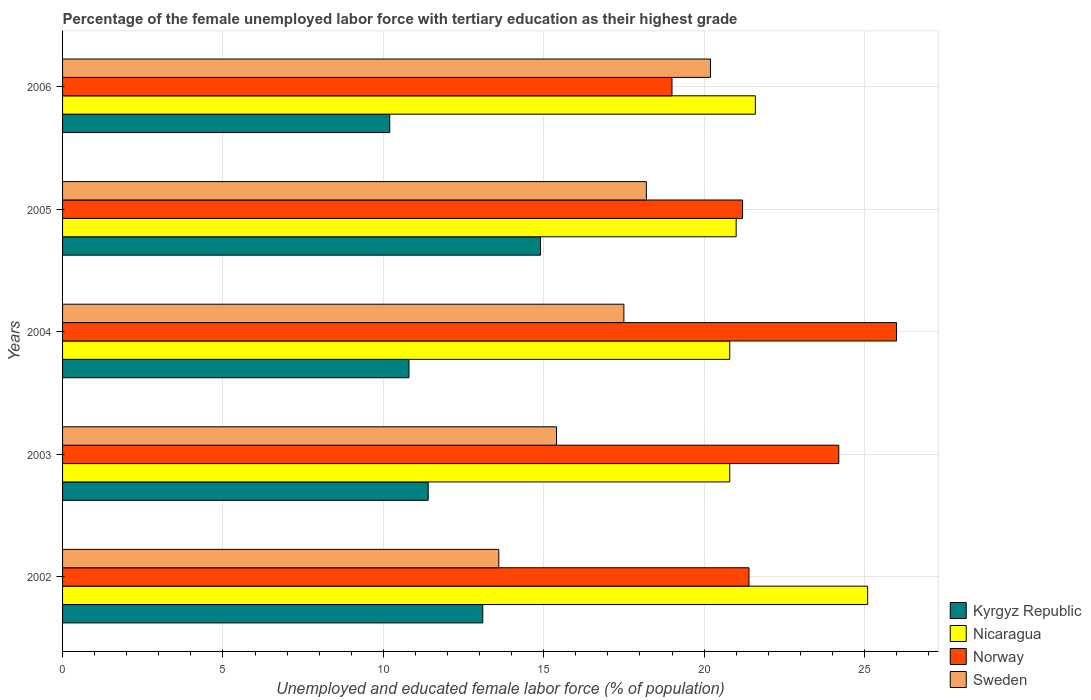How many groups of bars are there?
Your answer should be compact. 5. How many bars are there on the 5th tick from the top?
Your answer should be compact. 4. How many bars are there on the 2nd tick from the bottom?
Provide a short and direct response. 4. What is the percentage of the unemployed female labor force with tertiary education in Sweden in 2003?
Make the answer very short. 15.4. Across all years, what is the minimum percentage of the unemployed female labor force with tertiary education in Kyrgyz Republic?
Offer a terse response. 10.2. In which year was the percentage of the unemployed female labor force with tertiary education in Sweden maximum?
Offer a terse response. 2006. In which year was the percentage of the unemployed female labor force with tertiary education in Norway minimum?
Ensure brevity in your answer.  2006. What is the total percentage of the unemployed female labor force with tertiary education in Nicaragua in the graph?
Your response must be concise. 109.3. What is the difference between the percentage of the unemployed female labor force with tertiary education in Sweden in 2006 and the percentage of the unemployed female labor force with tertiary education in Nicaragua in 2003?
Your answer should be very brief. -0.6. What is the average percentage of the unemployed female labor force with tertiary education in Sweden per year?
Make the answer very short. 16.98. What is the ratio of the percentage of the unemployed female labor force with tertiary education in Sweden in 2002 to that in 2003?
Offer a very short reply. 0.88. Is the percentage of the unemployed female labor force with tertiary education in Nicaragua in 2003 less than that in 2005?
Ensure brevity in your answer.  Yes. What is the difference between the highest and the second highest percentage of the unemployed female labor force with tertiary education in Nicaragua?
Keep it short and to the point. 3.5. What is the difference between the highest and the lowest percentage of the unemployed female labor force with tertiary education in Sweden?
Make the answer very short. 6.6. What does the 4th bar from the top in 2006 represents?
Give a very brief answer. Kyrgyz Republic. What does the 2nd bar from the bottom in 2006 represents?
Your response must be concise. Nicaragua. Is it the case that in every year, the sum of the percentage of the unemployed female labor force with tertiary education in Kyrgyz Republic and percentage of the unemployed female labor force with tertiary education in Nicaragua is greater than the percentage of the unemployed female labor force with tertiary education in Norway?
Your answer should be very brief. Yes. How many bars are there?
Make the answer very short. 20. How many years are there in the graph?
Offer a terse response. 5. Are the values on the major ticks of X-axis written in scientific E-notation?
Keep it short and to the point. No. Does the graph contain any zero values?
Your answer should be very brief. No. How many legend labels are there?
Ensure brevity in your answer.  4. How are the legend labels stacked?
Provide a succinct answer. Vertical. What is the title of the graph?
Give a very brief answer. Percentage of the female unemployed labor force with tertiary education as their highest grade. Does "Belize" appear as one of the legend labels in the graph?
Offer a terse response. No. What is the label or title of the X-axis?
Offer a very short reply. Unemployed and educated female labor force (% of population). What is the Unemployed and educated female labor force (% of population) in Kyrgyz Republic in 2002?
Offer a very short reply. 13.1. What is the Unemployed and educated female labor force (% of population) of Nicaragua in 2002?
Provide a succinct answer. 25.1. What is the Unemployed and educated female labor force (% of population) of Norway in 2002?
Ensure brevity in your answer.  21.4. What is the Unemployed and educated female labor force (% of population) of Sweden in 2002?
Offer a terse response. 13.6. What is the Unemployed and educated female labor force (% of population) of Kyrgyz Republic in 2003?
Offer a terse response. 11.4. What is the Unemployed and educated female labor force (% of population) of Nicaragua in 2003?
Provide a short and direct response. 20.8. What is the Unemployed and educated female labor force (% of population) in Norway in 2003?
Offer a very short reply. 24.2. What is the Unemployed and educated female labor force (% of population) of Sweden in 2003?
Your response must be concise. 15.4. What is the Unemployed and educated female labor force (% of population) of Kyrgyz Republic in 2004?
Keep it short and to the point. 10.8. What is the Unemployed and educated female labor force (% of population) of Nicaragua in 2004?
Your answer should be compact. 20.8. What is the Unemployed and educated female labor force (% of population) in Norway in 2004?
Keep it short and to the point. 26. What is the Unemployed and educated female labor force (% of population) in Kyrgyz Republic in 2005?
Offer a very short reply. 14.9. What is the Unemployed and educated female labor force (% of population) in Nicaragua in 2005?
Your answer should be very brief. 21. What is the Unemployed and educated female labor force (% of population) of Norway in 2005?
Provide a short and direct response. 21.2. What is the Unemployed and educated female labor force (% of population) of Sweden in 2005?
Keep it short and to the point. 18.2. What is the Unemployed and educated female labor force (% of population) in Kyrgyz Republic in 2006?
Provide a short and direct response. 10.2. What is the Unemployed and educated female labor force (% of population) in Nicaragua in 2006?
Give a very brief answer. 21.6. What is the Unemployed and educated female labor force (% of population) of Sweden in 2006?
Offer a terse response. 20.2. Across all years, what is the maximum Unemployed and educated female labor force (% of population) of Kyrgyz Republic?
Offer a very short reply. 14.9. Across all years, what is the maximum Unemployed and educated female labor force (% of population) in Nicaragua?
Your response must be concise. 25.1. Across all years, what is the maximum Unemployed and educated female labor force (% of population) in Norway?
Your answer should be very brief. 26. Across all years, what is the maximum Unemployed and educated female labor force (% of population) of Sweden?
Provide a short and direct response. 20.2. Across all years, what is the minimum Unemployed and educated female labor force (% of population) in Kyrgyz Republic?
Your answer should be compact. 10.2. Across all years, what is the minimum Unemployed and educated female labor force (% of population) of Nicaragua?
Offer a terse response. 20.8. Across all years, what is the minimum Unemployed and educated female labor force (% of population) of Norway?
Keep it short and to the point. 19. Across all years, what is the minimum Unemployed and educated female labor force (% of population) of Sweden?
Your answer should be compact. 13.6. What is the total Unemployed and educated female labor force (% of population) in Kyrgyz Republic in the graph?
Offer a terse response. 60.4. What is the total Unemployed and educated female labor force (% of population) in Nicaragua in the graph?
Make the answer very short. 109.3. What is the total Unemployed and educated female labor force (% of population) in Norway in the graph?
Your answer should be very brief. 111.8. What is the total Unemployed and educated female labor force (% of population) in Sweden in the graph?
Make the answer very short. 84.9. What is the difference between the Unemployed and educated female labor force (% of population) of Norway in 2002 and that in 2004?
Your answer should be compact. -4.6. What is the difference between the Unemployed and educated female labor force (% of population) of Sweden in 2002 and that in 2004?
Ensure brevity in your answer.  -3.9. What is the difference between the Unemployed and educated female labor force (% of population) of Norway in 2002 and that in 2005?
Offer a very short reply. 0.2. What is the difference between the Unemployed and educated female labor force (% of population) of Sweden in 2002 and that in 2005?
Your response must be concise. -4.6. What is the difference between the Unemployed and educated female labor force (% of population) of Kyrgyz Republic in 2002 and that in 2006?
Offer a terse response. 2.9. What is the difference between the Unemployed and educated female labor force (% of population) in Sweden in 2002 and that in 2006?
Keep it short and to the point. -6.6. What is the difference between the Unemployed and educated female labor force (% of population) in Kyrgyz Republic in 2003 and that in 2004?
Your response must be concise. 0.6. What is the difference between the Unemployed and educated female labor force (% of population) of Nicaragua in 2003 and that in 2004?
Your answer should be compact. 0. What is the difference between the Unemployed and educated female labor force (% of population) of Norway in 2003 and that in 2005?
Give a very brief answer. 3. What is the difference between the Unemployed and educated female labor force (% of population) of Sweden in 2003 and that in 2006?
Make the answer very short. -4.8. What is the difference between the Unemployed and educated female labor force (% of population) in Kyrgyz Republic in 2004 and that in 2005?
Make the answer very short. -4.1. What is the difference between the Unemployed and educated female labor force (% of population) in Nicaragua in 2004 and that in 2005?
Ensure brevity in your answer.  -0.2. What is the difference between the Unemployed and educated female labor force (% of population) in Norway in 2004 and that in 2005?
Your response must be concise. 4.8. What is the difference between the Unemployed and educated female labor force (% of population) in Sweden in 2004 and that in 2005?
Provide a succinct answer. -0.7. What is the difference between the Unemployed and educated female labor force (% of population) in Kyrgyz Republic in 2004 and that in 2006?
Offer a terse response. 0.6. What is the difference between the Unemployed and educated female labor force (% of population) of Nicaragua in 2004 and that in 2006?
Your answer should be compact. -0.8. What is the difference between the Unemployed and educated female labor force (% of population) in Sweden in 2004 and that in 2006?
Offer a very short reply. -2.7. What is the difference between the Unemployed and educated female labor force (% of population) in Sweden in 2005 and that in 2006?
Ensure brevity in your answer.  -2. What is the difference between the Unemployed and educated female labor force (% of population) of Kyrgyz Republic in 2002 and the Unemployed and educated female labor force (% of population) of Norway in 2003?
Keep it short and to the point. -11.1. What is the difference between the Unemployed and educated female labor force (% of population) in Nicaragua in 2002 and the Unemployed and educated female labor force (% of population) in Norway in 2003?
Your answer should be compact. 0.9. What is the difference between the Unemployed and educated female labor force (% of population) in Nicaragua in 2002 and the Unemployed and educated female labor force (% of population) in Sweden in 2003?
Make the answer very short. 9.7. What is the difference between the Unemployed and educated female labor force (% of population) of Kyrgyz Republic in 2002 and the Unemployed and educated female labor force (% of population) of Nicaragua in 2004?
Keep it short and to the point. -7.7. What is the difference between the Unemployed and educated female labor force (% of population) in Kyrgyz Republic in 2002 and the Unemployed and educated female labor force (% of population) in Norway in 2004?
Your answer should be very brief. -12.9. What is the difference between the Unemployed and educated female labor force (% of population) of Nicaragua in 2002 and the Unemployed and educated female labor force (% of population) of Norway in 2004?
Make the answer very short. -0.9. What is the difference between the Unemployed and educated female labor force (% of population) of Nicaragua in 2002 and the Unemployed and educated female labor force (% of population) of Sweden in 2004?
Offer a terse response. 7.6. What is the difference between the Unemployed and educated female labor force (% of population) in Norway in 2002 and the Unemployed and educated female labor force (% of population) in Sweden in 2004?
Your answer should be compact. 3.9. What is the difference between the Unemployed and educated female labor force (% of population) in Kyrgyz Republic in 2002 and the Unemployed and educated female labor force (% of population) in Nicaragua in 2005?
Your answer should be compact. -7.9. What is the difference between the Unemployed and educated female labor force (% of population) in Kyrgyz Republic in 2002 and the Unemployed and educated female labor force (% of population) in Norway in 2005?
Offer a very short reply. -8.1. What is the difference between the Unemployed and educated female labor force (% of population) in Kyrgyz Republic in 2002 and the Unemployed and educated female labor force (% of population) in Sweden in 2005?
Make the answer very short. -5.1. What is the difference between the Unemployed and educated female labor force (% of population) of Norway in 2002 and the Unemployed and educated female labor force (% of population) of Sweden in 2005?
Make the answer very short. 3.2. What is the difference between the Unemployed and educated female labor force (% of population) of Kyrgyz Republic in 2002 and the Unemployed and educated female labor force (% of population) of Nicaragua in 2006?
Your answer should be very brief. -8.5. What is the difference between the Unemployed and educated female labor force (% of population) in Kyrgyz Republic in 2002 and the Unemployed and educated female labor force (% of population) in Norway in 2006?
Your response must be concise. -5.9. What is the difference between the Unemployed and educated female labor force (% of population) in Nicaragua in 2002 and the Unemployed and educated female labor force (% of population) in Norway in 2006?
Offer a very short reply. 6.1. What is the difference between the Unemployed and educated female labor force (% of population) of Kyrgyz Republic in 2003 and the Unemployed and educated female labor force (% of population) of Norway in 2004?
Offer a very short reply. -14.6. What is the difference between the Unemployed and educated female labor force (% of population) in Kyrgyz Republic in 2003 and the Unemployed and educated female labor force (% of population) in Sweden in 2004?
Offer a very short reply. -6.1. What is the difference between the Unemployed and educated female labor force (% of population) in Kyrgyz Republic in 2003 and the Unemployed and educated female labor force (% of population) in Norway in 2005?
Your response must be concise. -9.8. What is the difference between the Unemployed and educated female labor force (% of population) in Kyrgyz Republic in 2003 and the Unemployed and educated female labor force (% of population) in Sweden in 2005?
Offer a very short reply. -6.8. What is the difference between the Unemployed and educated female labor force (% of population) of Nicaragua in 2003 and the Unemployed and educated female labor force (% of population) of Sweden in 2005?
Ensure brevity in your answer.  2.6. What is the difference between the Unemployed and educated female labor force (% of population) in Norway in 2003 and the Unemployed and educated female labor force (% of population) in Sweden in 2005?
Offer a terse response. 6. What is the difference between the Unemployed and educated female labor force (% of population) of Kyrgyz Republic in 2003 and the Unemployed and educated female labor force (% of population) of Nicaragua in 2006?
Provide a succinct answer. -10.2. What is the difference between the Unemployed and educated female labor force (% of population) in Nicaragua in 2003 and the Unemployed and educated female labor force (% of population) in Sweden in 2006?
Give a very brief answer. 0.6. What is the difference between the Unemployed and educated female labor force (% of population) in Kyrgyz Republic in 2004 and the Unemployed and educated female labor force (% of population) in Norway in 2005?
Offer a very short reply. -10.4. What is the difference between the Unemployed and educated female labor force (% of population) in Nicaragua in 2004 and the Unemployed and educated female labor force (% of population) in Norway in 2005?
Your answer should be very brief. -0.4. What is the difference between the Unemployed and educated female labor force (% of population) in Nicaragua in 2004 and the Unemployed and educated female labor force (% of population) in Sweden in 2005?
Offer a very short reply. 2.6. What is the difference between the Unemployed and educated female labor force (% of population) of Norway in 2004 and the Unemployed and educated female labor force (% of population) of Sweden in 2005?
Provide a short and direct response. 7.8. What is the difference between the Unemployed and educated female labor force (% of population) of Kyrgyz Republic in 2004 and the Unemployed and educated female labor force (% of population) of Nicaragua in 2006?
Your response must be concise. -10.8. What is the difference between the Unemployed and educated female labor force (% of population) of Kyrgyz Republic in 2004 and the Unemployed and educated female labor force (% of population) of Norway in 2006?
Provide a succinct answer. -8.2. What is the difference between the Unemployed and educated female labor force (% of population) in Kyrgyz Republic in 2004 and the Unemployed and educated female labor force (% of population) in Sweden in 2006?
Your response must be concise. -9.4. What is the difference between the Unemployed and educated female labor force (% of population) in Nicaragua in 2004 and the Unemployed and educated female labor force (% of population) in Norway in 2006?
Your answer should be compact. 1.8. What is the difference between the Unemployed and educated female labor force (% of population) in Norway in 2004 and the Unemployed and educated female labor force (% of population) in Sweden in 2006?
Offer a terse response. 5.8. What is the difference between the Unemployed and educated female labor force (% of population) of Kyrgyz Republic in 2005 and the Unemployed and educated female labor force (% of population) of Nicaragua in 2006?
Your answer should be very brief. -6.7. What is the difference between the Unemployed and educated female labor force (% of population) of Kyrgyz Republic in 2005 and the Unemployed and educated female labor force (% of population) of Norway in 2006?
Make the answer very short. -4.1. What is the difference between the Unemployed and educated female labor force (% of population) of Kyrgyz Republic in 2005 and the Unemployed and educated female labor force (% of population) of Sweden in 2006?
Provide a succinct answer. -5.3. What is the average Unemployed and educated female labor force (% of population) of Kyrgyz Republic per year?
Your response must be concise. 12.08. What is the average Unemployed and educated female labor force (% of population) in Nicaragua per year?
Your response must be concise. 21.86. What is the average Unemployed and educated female labor force (% of population) of Norway per year?
Make the answer very short. 22.36. What is the average Unemployed and educated female labor force (% of population) of Sweden per year?
Make the answer very short. 16.98. In the year 2002, what is the difference between the Unemployed and educated female labor force (% of population) of Kyrgyz Republic and Unemployed and educated female labor force (% of population) of Nicaragua?
Offer a very short reply. -12. In the year 2002, what is the difference between the Unemployed and educated female labor force (% of population) in Kyrgyz Republic and Unemployed and educated female labor force (% of population) in Sweden?
Give a very brief answer. -0.5. In the year 2002, what is the difference between the Unemployed and educated female labor force (% of population) in Norway and Unemployed and educated female labor force (% of population) in Sweden?
Provide a succinct answer. 7.8. In the year 2003, what is the difference between the Unemployed and educated female labor force (% of population) of Kyrgyz Republic and Unemployed and educated female labor force (% of population) of Norway?
Provide a succinct answer. -12.8. In the year 2003, what is the difference between the Unemployed and educated female labor force (% of population) in Nicaragua and Unemployed and educated female labor force (% of population) in Sweden?
Provide a short and direct response. 5.4. In the year 2003, what is the difference between the Unemployed and educated female labor force (% of population) in Norway and Unemployed and educated female labor force (% of population) in Sweden?
Give a very brief answer. 8.8. In the year 2004, what is the difference between the Unemployed and educated female labor force (% of population) in Kyrgyz Republic and Unemployed and educated female labor force (% of population) in Nicaragua?
Ensure brevity in your answer.  -10. In the year 2004, what is the difference between the Unemployed and educated female labor force (% of population) in Kyrgyz Republic and Unemployed and educated female labor force (% of population) in Norway?
Provide a succinct answer. -15.2. In the year 2004, what is the difference between the Unemployed and educated female labor force (% of population) of Nicaragua and Unemployed and educated female labor force (% of population) of Norway?
Your answer should be compact. -5.2. In the year 2004, what is the difference between the Unemployed and educated female labor force (% of population) in Norway and Unemployed and educated female labor force (% of population) in Sweden?
Your answer should be very brief. 8.5. In the year 2005, what is the difference between the Unemployed and educated female labor force (% of population) in Kyrgyz Republic and Unemployed and educated female labor force (% of population) in Nicaragua?
Make the answer very short. -6.1. In the year 2005, what is the difference between the Unemployed and educated female labor force (% of population) of Kyrgyz Republic and Unemployed and educated female labor force (% of population) of Norway?
Keep it short and to the point. -6.3. In the year 2005, what is the difference between the Unemployed and educated female labor force (% of population) of Nicaragua and Unemployed and educated female labor force (% of population) of Sweden?
Keep it short and to the point. 2.8. In the year 2006, what is the difference between the Unemployed and educated female labor force (% of population) of Kyrgyz Republic and Unemployed and educated female labor force (% of population) of Nicaragua?
Your answer should be very brief. -11.4. In the year 2006, what is the difference between the Unemployed and educated female labor force (% of population) in Kyrgyz Republic and Unemployed and educated female labor force (% of population) in Norway?
Your response must be concise. -8.8. In the year 2006, what is the difference between the Unemployed and educated female labor force (% of population) in Kyrgyz Republic and Unemployed and educated female labor force (% of population) in Sweden?
Provide a succinct answer. -10. What is the ratio of the Unemployed and educated female labor force (% of population) of Kyrgyz Republic in 2002 to that in 2003?
Ensure brevity in your answer.  1.15. What is the ratio of the Unemployed and educated female labor force (% of population) of Nicaragua in 2002 to that in 2003?
Ensure brevity in your answer.  1.21. What is the ratio of the Unemployed and educated female labor force (% of population) in Norway in 2002 to that in 2003?
Provide a short and direct response. 0.88. What is the ratio of the Unemployed and educated female labor force (% of population) of Sweden in 2002 to that in 2003?
Your answer should be very brief. 0.88. What is the ratio of the Unemployed and educated female labor force (% of population) in Kyrgyz Republic in 2002 to that in 2004?
Provide a short and direct response. 1.21. What is the ratio of the Unemployed and educated female labor force (% of population) of Nicaragua in 2002 to that in 2004?
Your response must be concise. 1.21. What is the ratio of the Unemployed and educated female labor force (% of population) in Norway in 2002 to that in 2004?
Your answer should be compact. 0.82. What is the ratio of the Unemployed and educated female labor force (% of population) of Sweden in 2002 to that in 2004?
Give a very brief answer. 0.78. What is the ratio of the Unemployed and educated female labor force (% of population) in Kyrgyz Republic in 2002 to that in 2005?
Your answer should be very brief. 0.88. What is the ratio of the Unemployed and educated female labor force (% of population) in Nicaragua in 2002 to that in 2005?
Offer a terse response. 1.2. What is the ratio of the Unemployed and educated female labor force (% of population) in Norway in 2002 to that in 2005?
Keep it short and to the point. 1.01. What is the ratio of the Unemployed and educated female labor force (% of population) of Sweden in 2002 to that in 2005?
Give a very brief answer. 0.75. What is the ratio of the Unemployed and educated female labor force (% of population) in Kyrgyz Republic in 2002 to that in 2006?
Ensure brevity in your answer.  1.28. What is the ratio of the Unemployed and educated female labor force (% of population) of Nicaragua in 2002 to that in 2006?
Ensure brevity in your answer.  1.16. What is the ratio of the Unemployed and educated female labor force (% of population) of Norway in 2002 to that in 2006?
Offer a very short reply. 1.13. What is the ratio of the Unemployed and educated female labor force (% of population) in Sweden in 2002 to that in 2006?
Offer a very short reply. 0.67. What is the ratio of the Unemployed and educated female labor force (% of population) of Kyrgyz Republic in 2003 to that in 2004?
Your response must be concise. 1.06. What is the ratio of the Unemployed and educated female labor force (% of population) in Norway in 2003 to that in 2004?
Your answer should be very brief. 0.93. What is the ratio of the Unemployed and educated female labor force (% of population) in Sweden in 2003 to that in 2004?
Your response must be concise. 0.88. What is the ratio of the Unemployed and educated female labor force (% of population) of Kyrgyz Republic in 2003 to that in 2005?
Keep it short and to the point. 0.77. What is the ratio of the Unemployed and educated female labor force (% of population) of Nicaragua in 2003 to that in 2005?
Offer a very short reply. 0.99. What is the ratio of the Unemployed and educated female labor force (% of population) of Norway in 2003 to that in 2005?
Ensure brevity in your answer.  1.14. What is the ratio of the Unemployed and educated female labor force (% of population) in Sweden in 2003 to that in 2005?
Your answer should be compact. 0.85. What is the ratio of the Unemployed and educated female labor force (% of population) in Kyrgyz Republic in 2003 to that in 2006?
Provide a succinct answer. 1.12. What is the ratio of the Unemployed and educated female labor force (% of population) in Norway in 2003 to that in 2006?
Ensure brevity in your answer.  1.27. What is the ratio of the Unemployed and educated female labor force (% of population) in Sweden in 2003 to that in 2006?
Your answer should be compact. 0.76. What is the ratio of the Unemployed and educated female labor force (% of population) of Kyrgyz Republic in 2004 to that in 2005?
Keep it short and to the point. 0.72. What is the ratio of the Unemployed and educated female labor force (% of population) in Norway in 2004 to that in 2005?
Provide a succinct answer. 1.23. What is the ratio of the Unemployed and educated female labor force (% of population) of Sweden in 2004 to that in 2005?
Your answer should be very brief. 0.96. What is the ratio of the Unemployed and educated female labor force (% of population) in Kyrgyz Republic in 2004 to that in 2006?
Offer a terse response. 1.06. What is the ratio of the Unemployed and educated female labor force (% of population) of Norway in 2004 to that in 2006?
Your answer should be compact. 1.37. What is the ratio of the Unemployed and educated female labor force (% of population) of Sweden in 2004 to that in 2006?
Ensure brevity in your answer.  0.87. What is the ratio of the Unemployed and educated female labor force (% of population) of Kyrgyz Republic in 2005 to that in 2006?
Keep it short and to the point. 1.46. What is the ratio of the Unemployed and educated female labor force (% of population) of Nicaragua in 2005 to that in 2006?
Ensure brevity in your answer.  0.97. What is the ratio of the Unemployed and educated female labor force (% of population) in Norway in 2005 to that in 2006?
Offer a terse response. 1.12. What is the ratio of the Unemployed and educated female labor force (% of population) of Sweden in 2005 to that in 2006?
Keep it short and to the point. 0.9. What is the difference between the highest and the second highest Unemployed and educated female labor force (% of population) in Norway?
Offer a very short reply. 1.8. What is the difference between the highest and the second highest Unemployed and educated female labor force (% of population) in Sweden?
Provide a short and direct response. 2. What is the difference between the highest and the lowest Unemployed and educated female labor force (% of population) of Norway?
Make the answer very short. 7. What is the difference between the highest and the lowest Unemployed and educated female labor force (% of population) of Sweden?
Give a very brief answer. 6.6. 